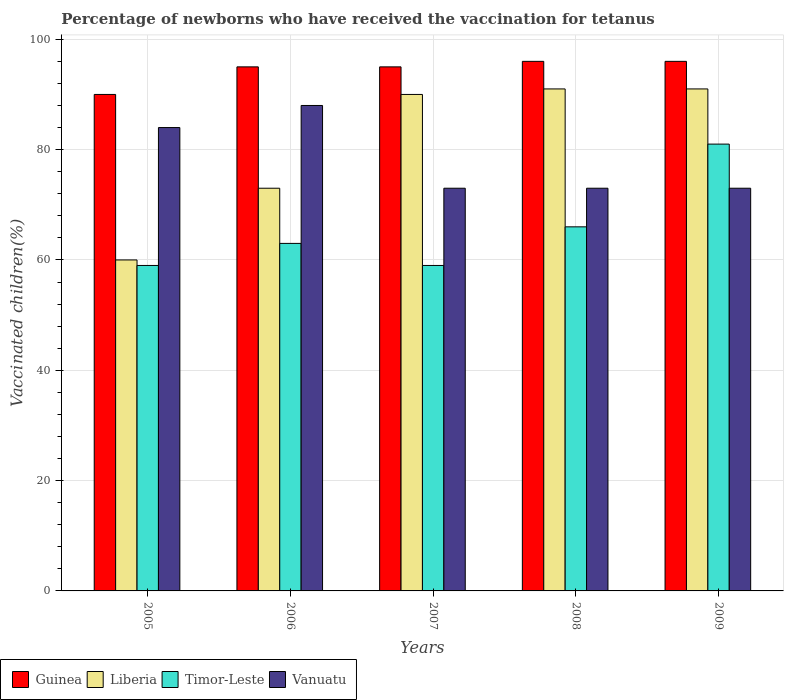How many different coloured bars are there?
Give a very brief answer. 4. How many groups of bars are there?
Ensure brevity in your answer.  5. In how many cases, is the number of bars for a given year not equal to the number of legend labels?
Your response must be concise. 0. Across all years, what is the minimum percentage of vaccinated children in Guinea?
Give a very brief answer. 90. In which year was the percentage of vaccinated children in Guinea maximum?
Your answer should be very brief. 2008. In which year was the percentage of vaccinated children in Guinea minimum?
Your answer should be very brief. 2005. What is the total percentage of vaccinated children in Vanuatu in the graph?
Keep it short and to the point. 391. What is the average percentage of vaccinated children in Guinea per year?
Your response must be concise. 94.4. In the year 2009, what is the difference between the percentage of vaccinated children in Timor-Leste and percentage of vaccinated children in Guinea?
Provide a succinct answer. -15. What is the ratio of the percentage of vaccinated children in Liberia in 2006 to that in 2009?
Offer a terse response. 0.8. Is the percentage of vaccinated children in Liberia in 2006 less than that in 2009?
Your answer should be very brief. Yes. Is the difference between the percentage of vaccinated children in Timor-Leste in 2006 and 2009 greater than the difference between the percentage of vaccinated children in Guinea in 2006 and 2009?
Make the answer very short. No. What is the difference between the highest and the second highest percentage of vaccinated children in Guinea?
Provide a short and direct response. 0. What is the difference between the highest and the lowest percentage of vaccinated children in Liberia?
Your response must be concise. 31. In how many years, is the percentage of vaccinated children in Guinea greater than the average percentage of vaccinated children in Guinea taken over all years?
Ensure brevity in your answer.  4. What does the 1st bar from the left in 2005 represents?
Keep it short and to the point. Guinea. What does the 2nd bar from the right in 2007 represents?
Provide a short and direct response. Timor-Leste. Is it the case that in every year, the sum of the percentage of vaccinated children in Guinea and percentage of vaccinated children in Vanuatu is greater than the percentage of vaccinated children in Liberia?
Make the answer very short. Yes. What is the difference between two consecutive major ticks on the Y-axis?
Keep it short and to the point. 20. Are the values on the major ticks of Y-axis written in scientific E-notation?
Give a very brief answer. No. Where does the legend appear in the graph?
Provide a succinct answer. Bottom left. What is the title of the graph?
Make the answer very short. Percentage of newborns who have received the vaccination for tetanus. Does "Poland" appear as one of the legend labels in the graph?
Offer a terse response. No. What is the label or title of the X-axis?
Your answer should be compact. Years. What is the label or title of the Y-axis?
Your response must be concise. Vaccinated children(%). What is the Vaccinated children(%) of Timor-Leste in 2005?
Offer a terse response. 59. What is the Vaccinated children(%) in Guinea in 2006?
Make the answer very short. 95. What is the Vaccinated children(%) in Liberia in 2006?
Provide a succinct answer. 73. What is the Vaccinated children(%) in Vanuatu in 2006?
Keep it short and to the point. 88. What is the Vaccinated children(%) of Timor-Leste in 2007?
Offer a terse response. 59. What is the Vaccinated children(%) in Vanuatu in 2007?
Provide a succinct answer. 73. What is the Vaccinated children(%) of Guinea in 2008?
Provide a succinct answer. 96. What is the Vaccinated children(%) in Liberia in 2008?
Ensure brevity in your answer.  91. What is the Vaccinated children(%) in Vanuatu in 2008?
Your answer should be compact. 73. What is the Vaccinated children(%) in Guinea in 2009?
Give a very brief answer. 96. What is the Vaccinated children(%) of Liberia in 2009?
Keep it short and to the point. 91. Across all years, what is the maximum Vaccinated children(%) of Guinea?
Your answer should be very brief. 96. Across all years, what is the maximum Vaccinated children(%) of Liberia?
Keep it short and to the point. 91. Across all years, what is the maximum Vaccinated children(%) in Timor-Leste?
Ensure brevity in your answer.  81. Across all years, what is the maximum Vaccinated children(%) of Vanuatu?
Your answer should be very brief. 88. Across all years, what is the minimum Vaccinated children(%) of Guinea?
Your answer should be very brief. 90. Across all years, what is the minimum Vaccinated children(%) in Vanuatu?
Ensure brevity in your answer.  73. What is the total Vaccinated children(%) in Guinea in the graph?
Provide a succinct answer. 472. What is the total Vaccinated children(%) in Liberia in the graph?
Keep it short and to the point. 405. What is the total Vaccinated children(%) of Timor-Leste in the graph?
Your answer should be compact. 328. What is the total Vaccinated children(%) of Vanuatu in the graph?
Provide a succinct answer. 391. What is the difference between the Vaccinated children(%) in Guinea in 2005 and that in 2006?
Your response must be concise. -5. What is the difference between the Vaccinated children(%) of Timor-Leste in 2005 and that in 2006?
Provide a short and direct response. -4. What is the difference between the Vaccinated children(%) of Vanuatu in 2005 and that in 2006?
Ensure brevity in your answer.  -4. What is the difference between the Vaccinated children(%) of Guinea in 2005 and that in 2007?
Provide a short and direct response. -5. What is the difference between the Vaccinated children(%) in Timor-Leste in 2005 and that in 2007?
Your answer should be compact. 0. What is the difference between the Vaccinated children(%) of Guinea in 2005 and that in 2008?
Your answer should be very brief. -6. What is the difference between the Vaccinated children(%) of Liberia in 2005 and that in 2008?
Make the answer very short. -31. What is the difference between the Vaccinated children(%) in Liberia in 2005 and that in 2009?
Give a very brief answer. -31. What is the difference between the Vaccinated children(%) in Timor-Leste in 2005 and that in 2009?
Offer a very short reply. -22. What is the difference between the Vaccinated children(%) of Vanuatu in 2005 and that in 2009?
Make the answer very short. 11. What is the difference between the Vaccinated children(%) in Guinea in 2006 and that in 2007?
Keep it short and to the point. 0. What is the difference between the Vaccinated children(%) in Vanuatu in 2006 and that in 2007?
Your answer should be very brief. 15. What is the difference between the Vaccinated children(%) of Liberia in 2006 and that in 2008?
Provide a succinct answer. -18. What is the difference between the Vaccinated children(%) in Timor-Leste in 2006 and that in 2008?
Ensure brevity in your answer.  -3. What is the difference between the Vaccinated children(%) of Vanuatu in 2006 and that in 2008?
Give a very brief answer. 15. What is the difference between the Vaccinated children(%) of Guinea in 2006 and that in 2009?
Your answer should be very brief. -1. What is the difference between the Vaccinated children(%) in Liberia in 2006 and that in 2009?
Make the answer very short. -18. What is the difference between the Vaccinated children(%) of Vanuatu in 2006 and that in 2009?
Make the answer very short. 15. What is the difference between the Vaccinated children(%) in Guinea in 2007 and that in 2008?
Offer a very short reply. -1. What is the difference between the Vaccinated children(%) in Timor-Leste in 2007 and that in 2008?
Make the answer very short. -7. What is the difference between the Vaccinated children(%) in Guinea in 2008 and that in 2009?
Give a very brief answer. 0. What is the difference between the Vaccinated children(%) of Liberia in 2008 and that in 2009?
Your response must be concise. 0. What is the difference between the Vaccinated children(%) in Vanuatu in 2008 and that in 2009?
Your response must be concise. 0. What is the difference between the Vaccinated children(%) in Guinea in 2005 and the Vaccinated children(%) in Liberia in 2006?
Your answer should be compact. 17. What is the difference between the Vaccinated children(%) in Guinea in 2005 and the Vaccinated children(%) in Vanuatu in 2006?
Keep it short and to the point. 2. What is the difference between the Vaccinated children(%) in Liberia in 2005 and the Vaccinated children(%) in Timor-Leste in 2006?
Your answer should be compact. -3. What is the difference between the Vaccinated children(%) of Liberia in 2005 and the Vaccinated children(%) of Vanuatu in 2006?
Ensure brevity in your answer.  -28. What is the difference between the Vaccinated children(%) in Timor-Leste in 2005 and the Vaccinated children(%) in Vanuatu in 2006?
Your answer should be compact. -29. What is the difference between the Vaccinated children(%) of Liberia in 2005 and the Vaccinated children(%) of Timor-Leste in 2007?
Your answer should be compact. 1. What is the difference between the Vaccinated children(%) in Liberia in 2005 and the Vaccinated children(%) in Vanuatu in 2007?
Your answer should be very brief. -13. What is the difference between the Vaccinated children(%) of Timor-Leste in 2005 and the Vaccinated children(%) of Vanuatu in 2007?
Provide a short and direct response. -14. What is the difference between the Vaccinated children(%) in Guinea in 2005 and the Vaccinated children(%) in Liberia in 2008?
Offer a very short reply. -1. What is the difference between the Vaccinated children(%) in Guinea in 2005 and the Vaccinated children(%) in Timor-Leste in 2008?
Provide a succinct answer. 24. What is the difference between the Vaccinated children(%) of Liberia in 2005 and the Vaccinated children(%) of Timor-Leste in 2008?
Give a very brief answer. -6. What is the difference between the Vaccinated children(%) in Guinea in 2005 and the Vaccinated children(%) in Liberia in 2009?
Offer a very short reply. -1. What is the difference between the Vaccinated children(%) of Guinea in 2005 and the Vaccinated children(%) of Vanuatu in 2009?
Your answer should be very brief. 17. What is the difference between the Vaccinated children(%) in Liberia in 2005 and the Vaccinated children(%) in Timor-Leste in 2009?
Ensure brevity in your answer.  -21. What is the difference between the Vaccinated children(%) of Liberia in 2005 and the Vaccinated children(%) of Vanuatu in 2009?
Offer a terse response. -13. What is the difference between the Vaccinated children(%) in Timor-Leste in 2005 and the Vaccinated children(%) in Vanuatu in 2009?
Offer a very short reply. -14. What is the difference between the Vaccinated children(%) in Guinea in 2006 and the Vaccinated children(%) in Timor-Leste in 2007?
Ensure brevity in your answer.  36. What is the difference between the Vaccinated children(%) in Liberia in 2006 and the Vaccinated children(%) in Timor-Leste in 2007?
Provide a succinct answer. 14. What is the difference between the Vaccinated children(%) of Liberia in 2006 and the Vaccinated children(%) of Timor-Leste in 2008?
Provide a succinct answer. 7. What is the difference between the Vaccinated children(%) of Liberia in 2006 and the Vaccinated children(%) of Vanuatu in 2008?
Your response must be concise. 0. What is the difference between the Vaccinated children(%) in Guinea in 2006 and the Vaccinated children(%) in Liberia in 2009?
Provide a succinct answer. 4. What is the difference between the Vaccinated children(%) of Guinea in 2006 and the Vaccinated children(%) of Timor-Leste in 2009?
Your answer should be very brief. 14. What is the difference between the Vaccinated children(%) of Timor-Leste in 2006 and the Vaccinated children(%) of Vanuatu in 2009?
Your answer should be very brief. -10. What is the difference between the Vaccinated children(%) of Guinea in 2007 and the Vaccinated children(%) of Liberia in 2008?
Ensure brevity in your answer.  4. What is the difference between the Vaccinated children(%) of Guinea in 2007 and the Vaccinated children(%) of Timor-Leste in 2008?
Give a very brief answer. 29. What is the difference between the Vaccinated children(%) of Guinea in 2007 and the Vaccinated children(%) of Vanuatu in 2008?
Make the answer very short. 22. What is the difference between the Vaccinated children(%) in Liberia in 2007 and the Vaccinated children(%) in Vanuatu in 2008?
Make the answer very short. 17. What is the difference between the Vaccinated children(%) of Guinea in 2007 and the Vaccinated children(%) of Liberia in 2009?
Your answer should be compact. 4. What is the difference between the Vaccinated children(%) in Liberia in 2007 and the Vaccinated children(%) in Vanuatu in 2009?
Make the answer very short. 17. What is the difference between the Vaccinated children(%) in Guinea in 2008 and the Vaccinated children(%) in Liberia in 2009?
Provide a short and direct response. 5. What is the difference between the Vaccinated children(%) of Guinea in 2008 and the Vaccinated children(%) of Vanuatu in 2009?
Provide a succinct answer. 23. What is the difference between the Vaccinated children(%) of Liberia in 2008 and the Vaccinated children(%) of Timor-Leste in 2009?
Your response must be concise. 10. What is the difference between the Vaccinated children(%) of Liberia in 2008 and the Vaccinated children(%) of Vanuatu in 2009?
Offer a very short reply. 18. What is the average Vaccinated children(%) of Guinea per year?
Your answer should be compact. 94.4. What is the average Vaccinated children(%) in Liberia per year?
Provide a succinct answer. 81. What is the average Vaccinated children(%) of Timor-Leste per year?
Give a very brief answer. 65.6. What is the average Vaccinated children(%) of Vanuatu per year?
Provide a succinct answer. 78.2. In the year 2005, what is the difference between the Vaccinated children(%) of Guinea and Vaccinated children(%) of Timor-Leste?
Provide a succinct answer. 31. In the year 2005, what is the difference between the Vaccinated children(%) of Liberia and Vaccinated children(%) of Timor-Leste?
Your answer should be very brief. 1. In the year 2005, what is the difference between the Vaccinated children(%) in Liberia and Vaccinated children(%) in Vanuatu?
Keep it short and to the point. -24. In the year 2006, what is the difference between the Vaccinated children(%) of Guinea and Vaccinated children(%) of Vanuatu?
Offer a very short reply. 7. In the year 2006, what is the difference between the Vaccinated children(%) of Liberia and Vaccinated children(%) of Timor-Leste?
Your answer should be compact. 10. In the year 2007, what is the difference between the Vaccinated children(%) in Guinea and Vaccinated children(%) in Liberia?
Give a very brief answer. 5. In the year 2007, what is the difference between the Vaccinated children(%) of Guinea and Vaccinated children(%) of Timor-Leste?
Offer a very short reply. 36. In the year 2007, what is the difference between the Vaccinated children(%) of Guinea and Vaccinated children(%) of Vanuatu?
Make the answer very short. 22. In the year 2007, what is the difference between the Vaccinated children(%) of Liberia and Vaccinated children(%) of Timor-Leste?
Make the answer very short. 31. In the year 2007, what is the difference between the Vaccinated children(%) in Timor-Leste and Vaccinated children(%) in Vanuatu?
Offer a terse response. -14. In the year 2008, what is the difference between the Vaccinated children(%) in Guinea and Vaccinated children(%) in Timor-Leste?
Offer a very short reply. 30. In the year 2008, what is the difference between the Vaccinated children(%) of Liberia and Vaccinated children(%) of Timor-Leste?
Your response must be concise. 25. In the year 2009, what is the difference between the Vaccinated children(%) of Guinea and Vaccinated children(%) of Liberia?
Offer a very short reply. 5. In the year 2009, what is the difference between the Vaccinated children(%) in Guinea and Vaccinated children(%) in Vanuatu?
Offer a terse response. 23. In the year 2009, what is the difference between the Vaccinated children(%) of Liberia and Vaccinated children(%) of Timor-Leste?
Keep it short and to the point. 10. In the year 2009, what is the difference between the Vaccinated children(%) in Timor-Leste and Vaccinated children(%) in Vanuatu?
Provide a short and direct response. 8. What is the ratio of the Vaccinated children(%) of Liberia in 2005 to that in 2006?
Give a very brief answer. 0.82. What is the ratio of the Vaccinated children(%) of Timor-Leste in 2005 to that in 2006?
Provide a short and direct response. 0.94. What is the ratio of the Vaccinated children(%) in Vanuatu in 2005 to that in 2006?
Offer a terse response. 0.95. What is the ratio of the Vaccinated children(%) in Guinea in 2005 to that in 2007?
Your answer should be compact. 0.95. What is the ratio of the Vaccinated children(%) of Liberia in 2005 to that in 2007?
Make the answer very short. 0.67. What is the ratio of the Vaccinated children(%) in Vanuatu in 2005 to that in 2007?
Keep it short and to the point. 1.15. What is the ratio of the Vaccinated children(%) of Liberia in 2005 to that in 2008?
Your answer should be very brief. 0.66. What is the ratio of the Vaccinated children(%) of Timor-Leste in 2005 to that in 2008?
Offer a terse response. 0.89. What is the ratio of the Vaccinated children(%) of Vanuatu in 2005 to that in 2008?
Make the answer very short. 1.15. What is the ratio of the Vaccinated children(%) in Liberia in 2005 to that in 2009?
Keep it short and to the point. 0.66. What is the ratio of the Vaccinated children(%) of Timor-Leste in 2005 to that in 2009?
Ensure brevity in your answer.  0.73. What is the ratio of the Vaccinated children(%) in Vanuatu in 2005 to that in 2009?
Your answer should be compact. 1.15. What is the ratio of the Vaccinated children(%) of Guinea in 2006 to that in 2007?
Your answer should be compact. 1. What is the ratio of the Vaccinated children(%) in Liberia in 2006 to that in 2007?
Offer a very short reply. 0.81. What is the ratio of the Vaccinated children(%) of Timor-Leste in 2006 to that in 2007?
Your answer should be very brief. 1.07. What is the ratio of the Vaccinated children(%) in Vanuatu in 2006 to that in 2007?
Provide a short and direct response. 1.21. What is the ratio of the Vaccinated children(%) of Guinea in 2006 to that in 2008?
Make the answer very short. 0.99. What is the ratio of the Vaccinated children(%) of Liberia in 2006 to that in 2008?
Keep it short and to the point. 0.8. What is the ratio of the Vaccinated children(%) in Timor-Leste in 2006 to that in 2008?
Keep it short and to the point. 0.95. What is the ratio of the Vaccinated children(%) in Vanuatu in 2006 to that in 2008?
Your answer should be very brief. 1.21. What is the ratio of the Vaccinated children(%) of Liberia in 2006 to that in 2009?
Your answer should be very brief. 0.8. What is the ratio of the Vaccinated children(%) in Timor-Leste in 2006 to that in 2009?
Your answer should be compact. 0.78. What is the ratio of the Vaccinated children(%) in Vanuatu in 2006 to that in 2009?
Keep it short and to the point. 1.21. What is the ratio of the Vaccinated children(%) in Liberia in 2007 to that in 2008?
Give a very brief answer. 0.99. What is the ratio of the Vaccinated children(%) of Timor-Leste in 2007 to that in 2008?
Offer a terse response. 0.89. What is the ratio of the Vaccinated children(%) in Guinea in 2007 to that in 2009?
Make the answer very short. 0.99. What is the ratio of the Vaccinated children(%) in Liberia in 2007 to that in 2009?
Your answer should be very brief. 0.99. What is the ratio of the Vaccinated children(%) of Timor-Leste in 2007 to that in 2009?
Ensure brevity in your answer.  0.73. What is the ratio of the Vaccinated children(%) of Vanuatu in 2007 to that in 2009?
Offer a terse response. 1. What is the ratio of the Vaccinated children(%) of Liberia in 2008 to that in 2009?
Offer a very short reply. 1. What is the ratio of the Vaccinated children(%) in Timor-Leste in 2008 to that in 2009?
Your answer should be very brief. 0.81. What is the difference between the highest and the second highest Vaccinated children(%) of Liberia?
Make the answer very short. 0. What is the difference between the highest and the second highest Vaccinated children(%) in Vanuatu?
Your answer should be compact. 4. What is the difference between the highest and the lowest Vaccinated children(%) in Guinea?
Your answer should be compact. 6. What is the difference between the highest and the lowest Vaccinated children(%) in Liberia?
Your answer should be very brief. 31. 